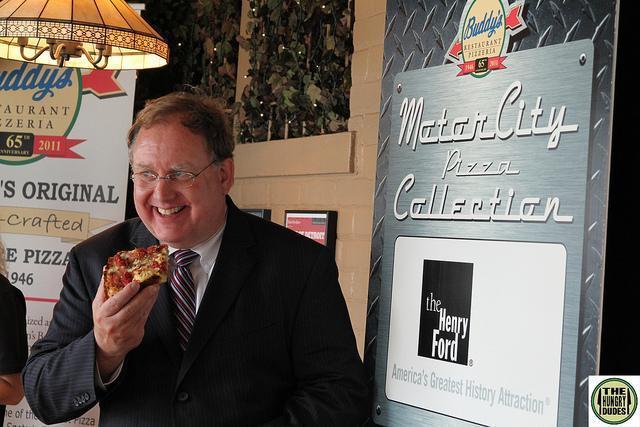How many people are visible?
Give a very brief answer. 2. 